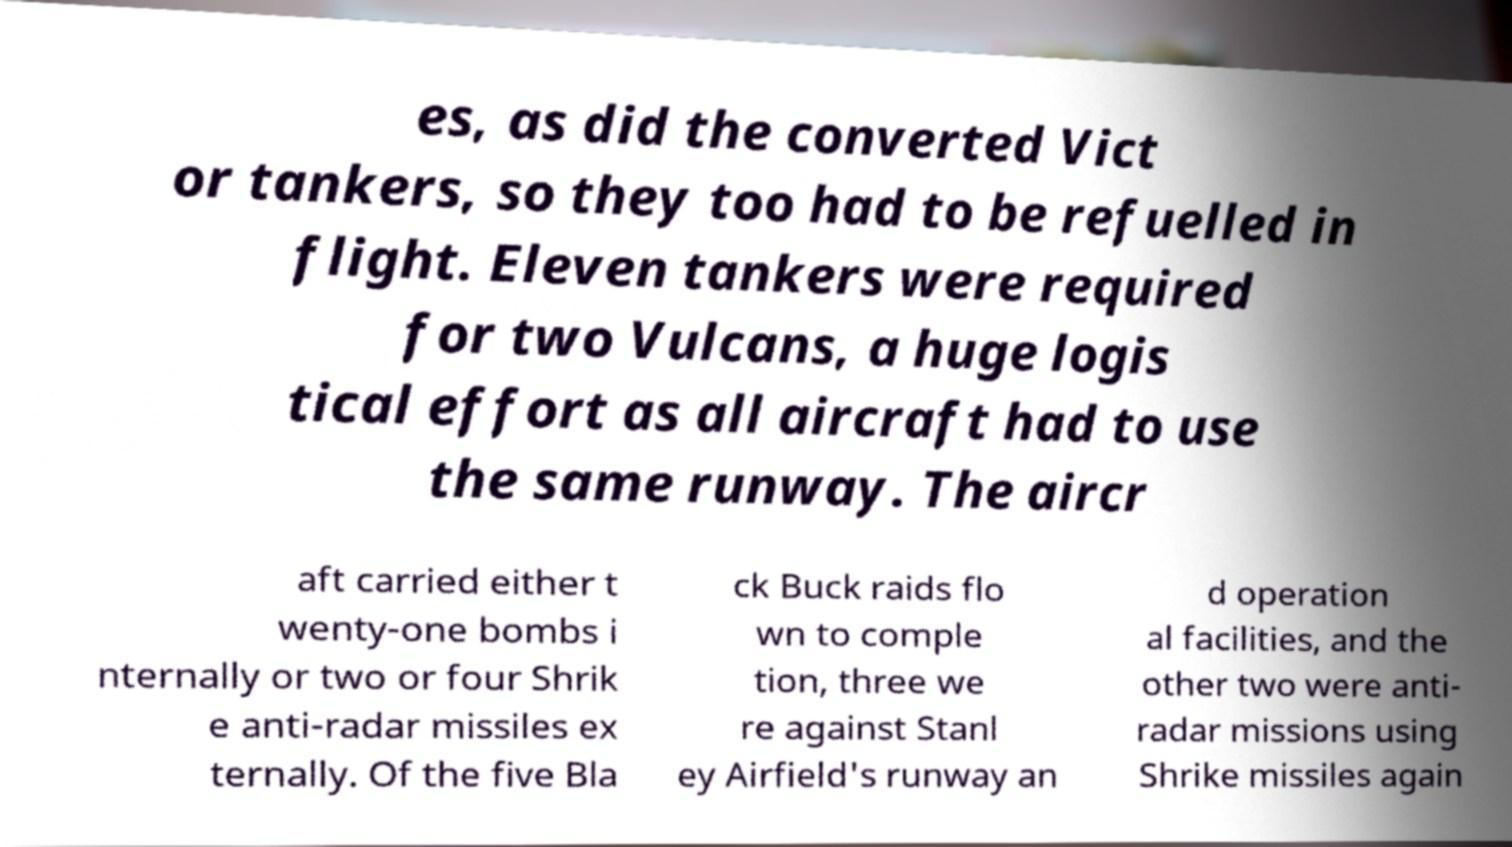Please identify and transcribe the text found in this image. es, as did the converted Vict or tankers, so they too had to be refuelled in flight. Eleven tankers were required for two Vulcans, a huge logis tical effort as all aircraft had to use the same runway. The aircr aft carried either t wenty-one bombs i nternally or two or four Shrik e anti-radar missiles ex ternally. Of the five Bla ck Buck raids flo wn to comple tion, three we re against Stanl ey Airfield's runway an d operation al facilities, and the other two were anti- radar missions using Shrike missiles again 